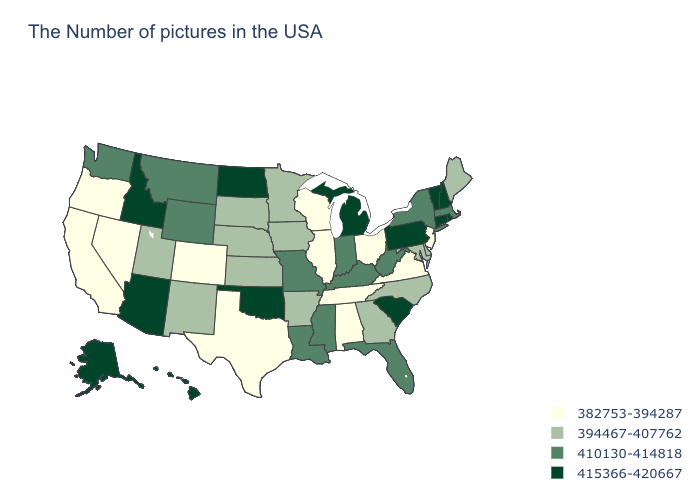What is the value of Washington?
Quick response, please. 410130-414818. Does Rhode Island have the highest value in the USA?
Answer briefly. Yes. What is the highest value in the USA?
Write a very short answer. 415366-420667. Name the states that have a value in the range 410130-414818?
Concise answer only. Massachusetts, New York, West Virginia, Florida, Kentucky, Indiana, Mississippi, Louisiana, Missouri, Wyoming, Montana, Washington. Name the states that have a value in the range 394467-407762?
Concise answer only. Maine, Delaware, Maryland, North Carolina, Georgia, Arkansas, Minnesota, Iowa, Kansas, Nebraska, South Dakota, New Mexico, Utah. Does Nebraska have the lowest value in the USA?
Short answer required. No. What is the value of Indiana?
Quick response, please. 410130-414818. How many symbols are there in the legend?
Be succinct. 4. Name the states that have a value in the range 410130-414818?
Write a very short answer. Massachusetts, New York, West Virginia, Florida, Kentucky, Indiana, Mississippi, Louisiana, Missouri, Wyoming, Montana, Washington. How many symbols are there in the legend?
Write a very short answer. 4. Which states have the lowest value in the USA?
Keep it brief. New Jersey, Virginia, Ohio, Alabama, Tennessee, Wisconsin, Illinois, Texas, Colorado, Nevada, California, Oregon. Which states have the lowest value in the Northeast?
Write a very short answer. New Jersey. Among the states that border Nebraska , does Kansas have the highest value?
Concise answer only. No. Which states have the lowest value in the USA?
Give a very brief answer. New Jersey, Virginia, Ohio, Alabama, Tennessee, Wisconsin, Illinois, Texas, Colorado, Nevada, California, Oregon. Name the states that have a value in the range 410130-414818?
Keep it brief. Massachusetts, New York, West Virginia, Florida, Kentucky, Indiana, Mississippi, Louisiana, Missouri, Wyoming, Montana, Washington. 